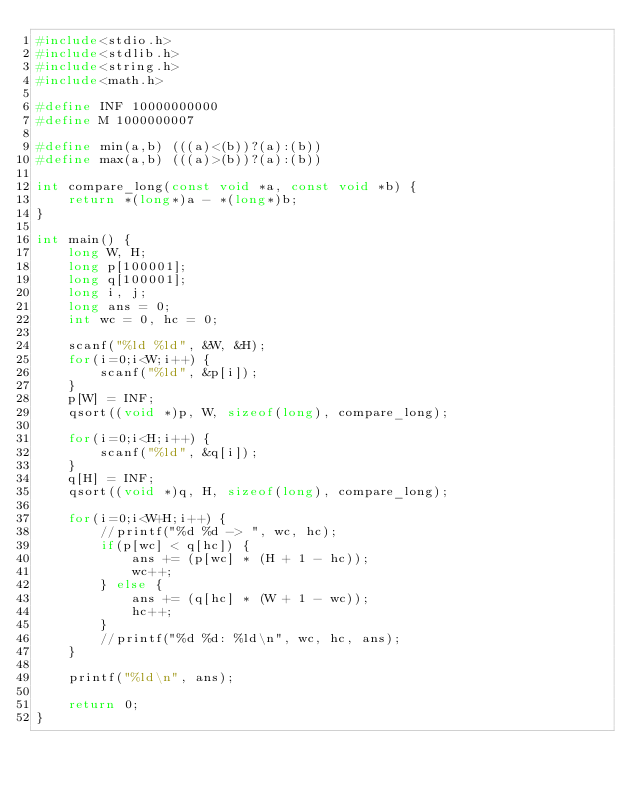<code> <loc_0><loc_0><loc_500><loc_500><_C_>#include<stdio.h>
#include<stdlib.h>
#include<string.h>
#include<math.h>
 
#define INF 10000000000
#define M 1000000007

#define min(a,b) (((a)<(b))?(a):(b))
#define max(a,b) (((a)>(b))?(a):(b))

int compare_long(const void *a, const void *b) {
	return *(long*)a - *(long*)b;
}

int main() {
	long W, H;
	long p[100001];
	long q[100001];
	long i, j;
	long ans = 0;
	int wc = 0, hc = 0;
	
	scanf("%ld %ld", &W, &H);
	for(i=0;i<W;i++) {
		scanf("%ld", &p[i]);
	}
	p[W] = INF;
	qsort((void *)p, W, sizeof(long), compare_long);
	
	for(i=0;i<H;i++) {
		scanf("%ld", &q[i]);
	}
	q[H] = INF;
	qsort((void *)q, H, sizeof(long), compare_long);
	
	for(i=0;i<W+H;i++) {
		//printf("%d %d -> ", wc, hc);
		if(p[wc] < q[hc]) {
			ans += (p[wc] * (H + 1 - hc));
			wc++;
		} else {
			ans += (q[hc] * (W + 1 - wc));
			hc++;
		}
		//printf("%d %d: %ld\n", wc, hc, ans);
	}
	
	printf("%ld\n", ans);
	
	return 0;
}</code> 